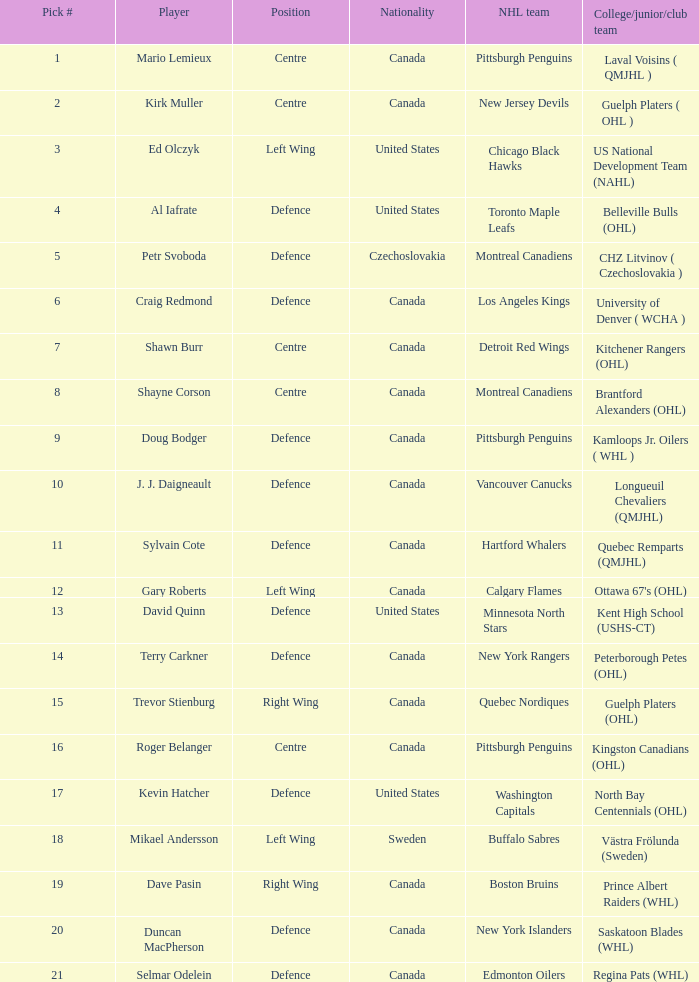Would you be able to parse every entry in this table? {'header': ['Pick #', 'Player', 'Position', 'Nationality', 'NHL team', 'College/junior/club team'], 'rows': [['1', 'Mario Lemieux', 'Centre', 'Canada', 'Pittsburgh Penguins', 'Laval Voisins ( QMJHL )'], ['2', 'Kirk Muller', 'Centre', 'Canada', 'New Jersey Devils', 'Guelph Platers ( OHL )'], ['3', 'Ed Olczyk', 'Left Wing', 'United States', 'Chicago Black Hawks', 'US National Development Team (NAHL)'], ['4', 'Al Iafrate', 'Defence', 'United States', 'Toronto Maple Leafs', 'Belleville Bulls (OHL)'], ['5', 'Petr Svoboda', 'Defence', 'Czechoslovakia', 'Montreal Canadiens', 'CHZ Litvinov ( Czechoslovakia )'], ['6', 'Craig Redmond', 'Defence', 'Canada', 'Los Angeles Kings', 'University of Denver ( WCHA )'], ['7', 'Shawn Burr', 'Centre', 'Canada', 'Detroit Red Wings', 'Kitchener Rangers (OHL)'], ['8', 'Shayne Corson', 'Centre', 'Canada', 'Montreal Canadiens', 'Brantford Alexanders (OHL)'], ['9', 'Doug Bodger', 'Defence', 'Canada', 'Pittsburgh Penguins', 'Kamloops Jr. Oilers ( WHL )'], ['10', 'J. J. Daigneault', 'Defence', 'Canada', 'Vancouver Canucks', 'Longueuil Chevaliers (QMJHL)'], ['11', 'Sylvain Cote', 'Defence', 'Canada', 'Hartford Whalers', 'Quebec Remparts (QMJHL)'], ['12', 'Gary Roberts', 'Left Wing', 'Canada', 'Calgary Flames', "Ottawa 67's (OHL)"], ['13', 'David Quinn', 'Defence', 'United States', 'Minnesota North Stars', 'Kent High School (USHS-CT)'], ['14', 'Terry Carkner', 'Defence', 'Canada', 'New York Rangers', 'Peterborough Petes (OHL)'], ['15', 'Trevor Stienburg', 'Right Wing', 'Canada', 'Quebec Nordiques', 'Guelph Platers (OHL)'], ['16', 'Roger Belanger', 'Centre', 'Canada', 'Pittsburgh Penguins', 'Kingston Canadians (OHL)'], ['17', 'Kevin Hatcher', 'Defence', 'United States', 'Washington Capitals', 'North Bay Centennials (OHL)'], ['18', 'Mikael Andersson', 'Left Wing', 'Sweden', 'Buffalo Sabres', 'Västra Frölunda (Sweden)'], ['19', 'Dave Pasin', 'Right Wing', 'Canada', 'Boston Bruins', 'Prince Albert Raiders (WHL)'], ['20', 'Duncan MacPherson', 'Defence', 'Canada', 'New York Islanders', 'Saskatoon Blades (WHL)'], ['21', 'Selmar Odelein', 'Defence', 'Canada', 'Edmonton Oilers', 'Regina Pats (WHL)']]} What daft pick number is the player coming from Regina Pats (WHL)? 21.0. 